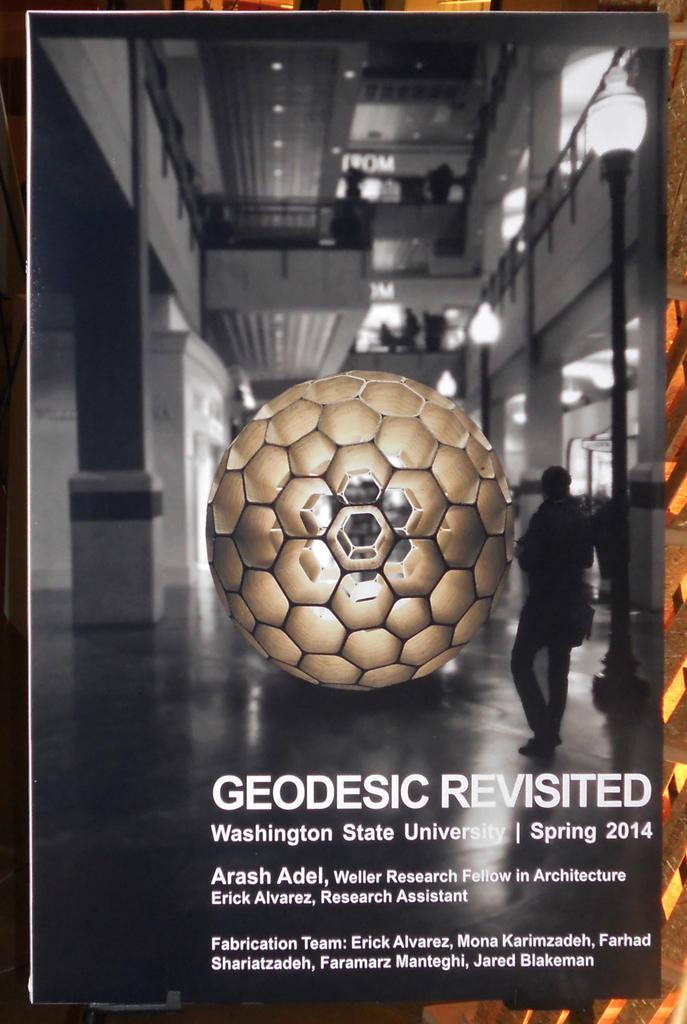What can be seen in the image? There is a photo frame in the image. What is inside the photo frame? The photo frame contains an object. Is there any text or writing associated with the object in the photo frame? Yes, there is writing below the object in the photo frame. Can you see a tongue inside the photo frame? No, there is no tongue present inside the photo frame in the image. 